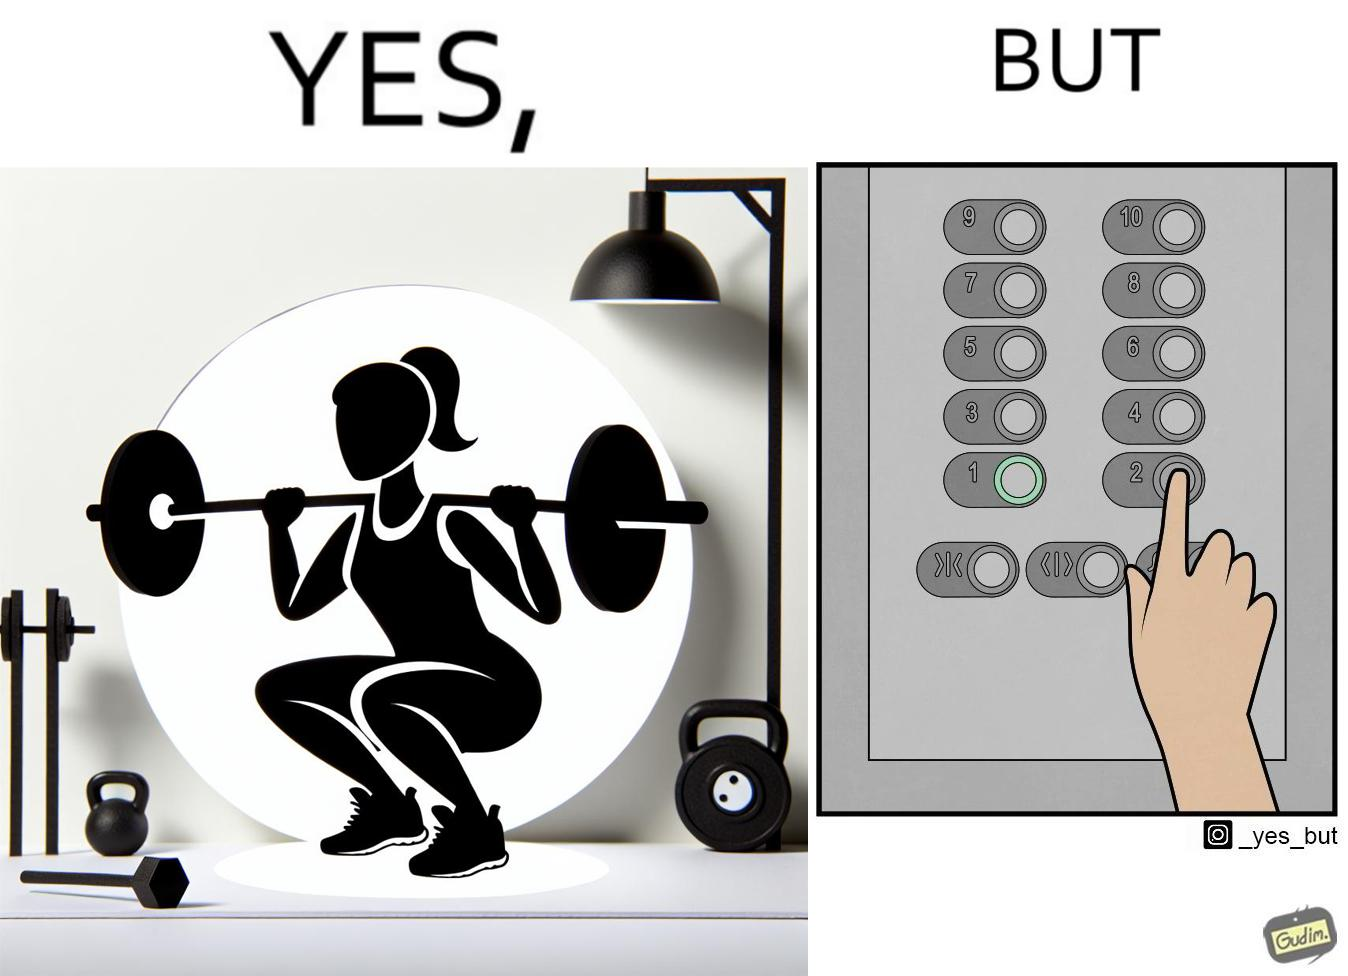Describe what you see in the left and right parts of this image. In the left part of the image: The image shows a women exercising with a bar bell in a gym. She is wearing a sport outfit. She is crouching down on one leg doing a single leg squat with a bar bell. In the right part of the image: The image shows the control panel inside of an elevator. The indicator for the first floor is green which means the button for the first floor was pressed. A hand is about to press the button for the second floor. 